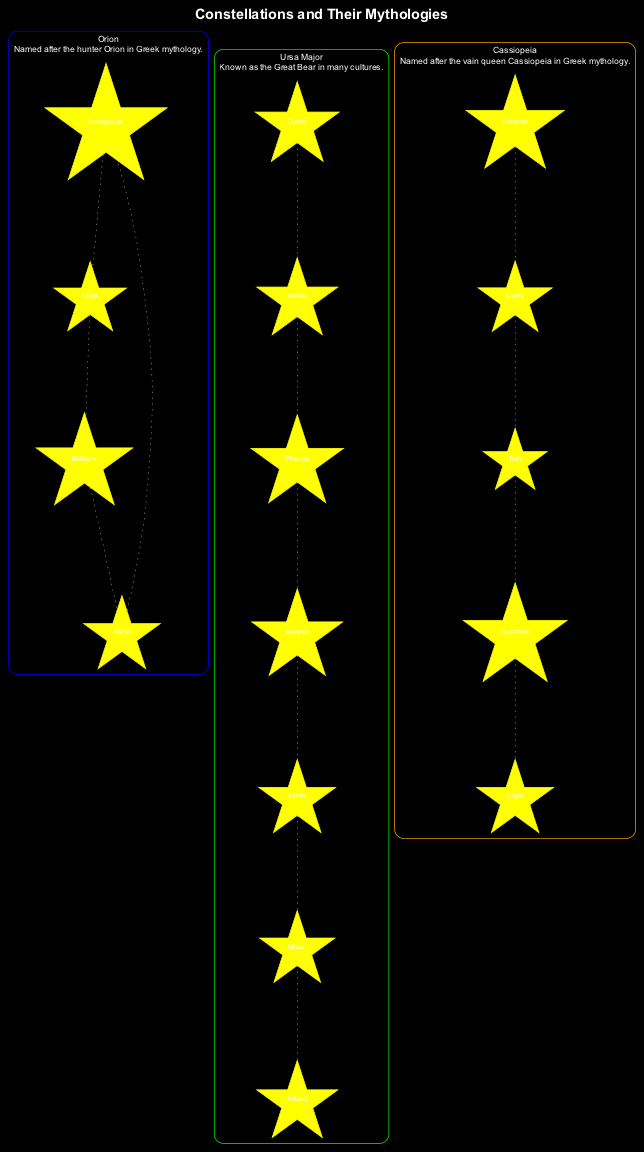What is the color of the border around Orion? The diagram indicates that Orion is highlighted with a blue border. This information is directly stated in the constellation's attributes.
Answer: blue How many stars are there in Ursa Major? The diagram lists seven stars associated with the constellation Ursa Major. This can be counted from the stars listed under the Ursa Major section.
Answer: seven What mythological figure is Cassiopeia named after? The description for Cassiopeia specifically states that it is named after the vain queen Cassiopeia from Greek mythology. This information can be found in the description section of the diagram.
Answer: vain queen List one star from the Orion constellation. The diagram provides four stars for Orion: Betelgeuse, Rigel, Bellatrix, and Saiph. Any one of these can be mentioned as the answer.
Answer: Betelgeuse Which constellation is known as the Great Bear? The description for Ursa Major explicitly refers to it as the Great Bear in many cultures. This key detail is presented under the constellation's description area.
Answer: Ursa Major How many dotted lines are drawn for Cassiopeia? The diagram shows four dotted lines connecting the stars in Cassiopeia. This information can be counted from the list of dotted lines under the Cassiopeia section.
Answer: four What color is the border around Ursa Major? The border color for Ursa Major is specified as green in the diagram's attributes for this constellation. This is stated directly under Ursa Major’s description.
Answer: green Which star connects to Betelgeuse in Orion via a dotted line? The diagram indicates that Betelgeuse is connected by a dotted line to Rigel, as shown in the list of dotted lines for the Orion constellation.
Answer: Rigel What is the primary theme of the diagram? The diagram's title explicitly indicates that the theme revolves around constellations and their mythologies, providing information on star patterns and associated stories.
Answer: constellations and their mythologies 